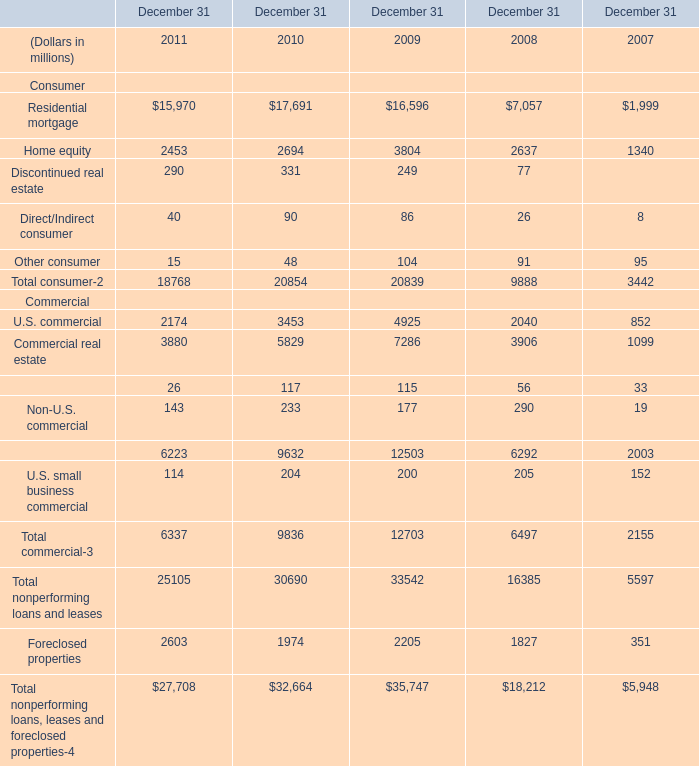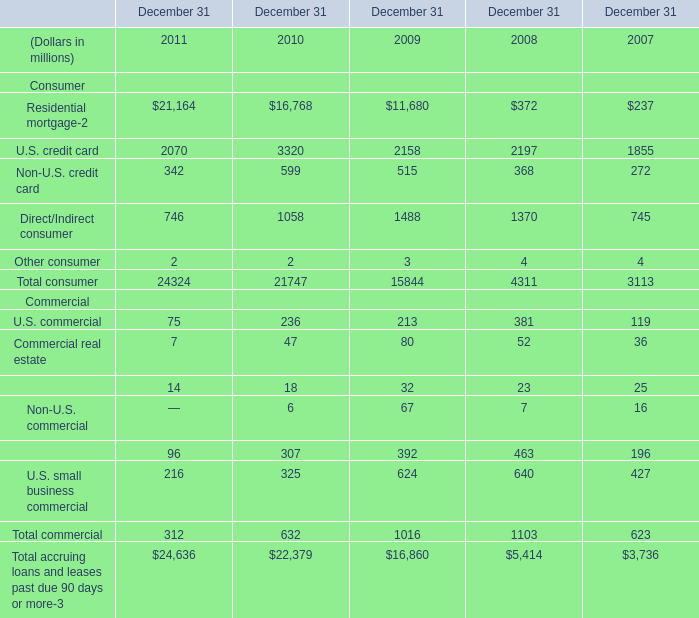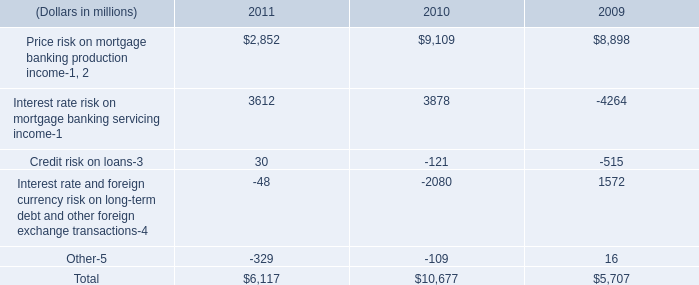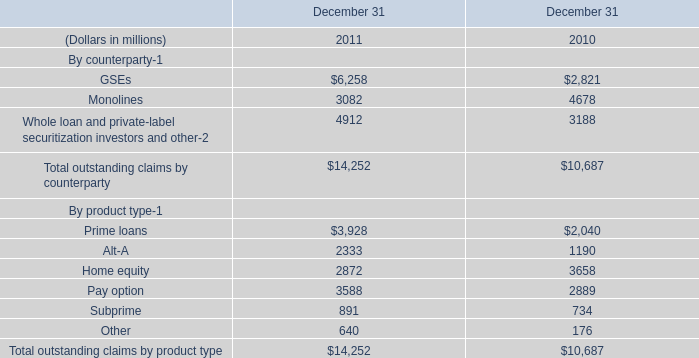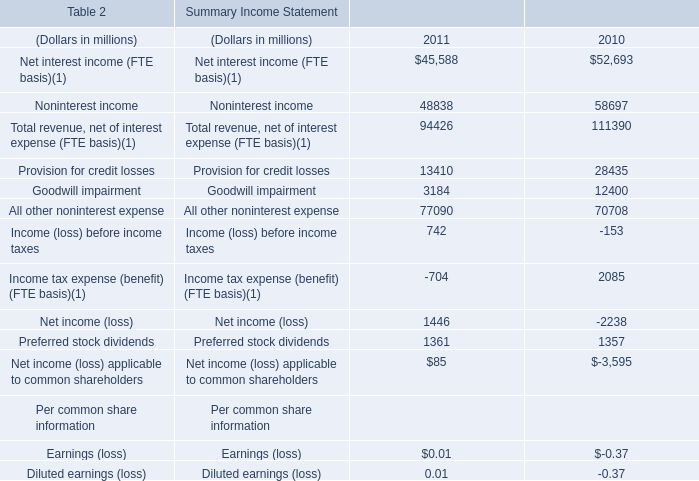What is the average amount of Home equity By product type of December 31 2011, and Residential mortgage of December 31 2011 ? 
Computations: ((2872.0 + 15970.0) / 2)
Answer: 9421.0. 